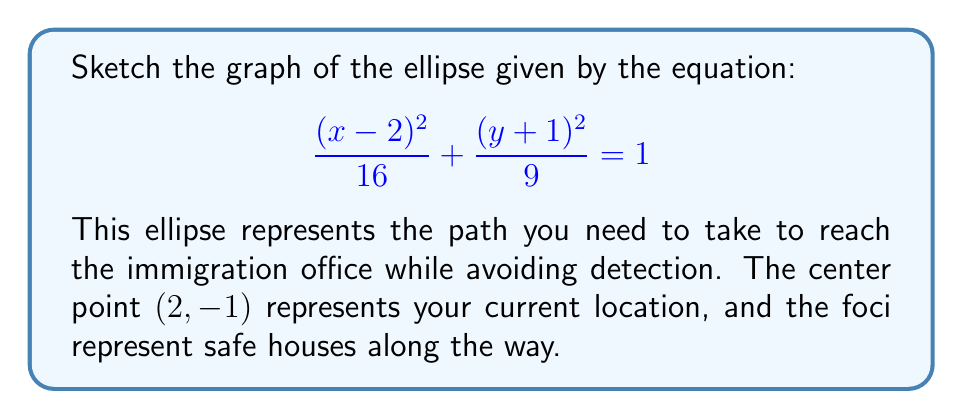Can you answer this question? To sketch the graph of this ellipse, we'll follow these steps:

1) Identify the center:
   The center is (h, k) = (2, -1)

2) Identify the semi-major and semi-minor axes:
   $a^2 = 16$, so $a = 4$
   $b^2 = 9$, so $b = 3$
   Since 16 > 9, the major axis is horizontal

3) Calculate the focal distance c:
   $c^2 = a^2 - b^2 = 16 - 9 = 7$
   $c = \sqrt{7} \approx 2.65$

4) Locate the vertices:
   (2 ± 4, -1)
   So, (6, -1) and (-2, -1)

5) Locate the co-vertices:
   (2, -1 ± 3)
   So, (2, 2) and (2, -4)

6) Locate the foci:
   (2 ± 2.65, -1)
   So, approximately (4.65, -1) and (-0.65, -1)

7) Sketch the ellipse:

[asy]
import graph;
size(200);
real a = 4;
real b = 3;
real c = sqrt(7);

pair center = (2,-1);
pair[] vertices = {(2+a,-1), (2-a,-1)};
pair[] co_vertices = {(2,-1+b), (2,-1-b)};
pair[] foci = {(2+c,-1), (2-c,-1)};

draw(ellipse(center, a, b), linewidth(2));
dot(center,red);
dot(vertices[0],blue);
dot(vertices[1],blue);
dot(co_vertices[0],green);
dot(co_vertices[1],green);
dot(foci[0],purple);
dot(foci[1],purple);

label("Center", center, NE);
label("Vertex", vertices[0], E);
label("Vertex", vertices[1], W);
label("Co-vertex", co_vertices[0], N);
label("Co-vertex", co_vertices[1], S);
label("Focus", foci[0], SE);
label("Focus", foci[1], SW);

xaxis("x", -4, 8);
yaxis("y", -5, 4);
[/asy]
Answer: Ellipse centered at (2, -1) with horizontal major axis 8 and vertical minor axis 6. 